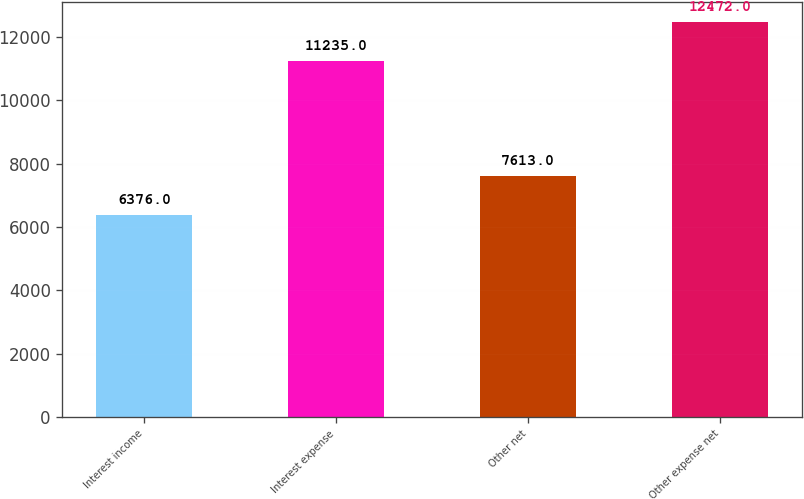Convert chart to OTSL. <chart><loc_0><loc_0><loc_500><loc_500><bar_chart><fcel>Interest income<fcel>Interest expense<fcel>Other net<fcel>Other expense net<nl><fcel>6376<fcel>11235<fcel>7613<fcel>12472<nl></chart> 